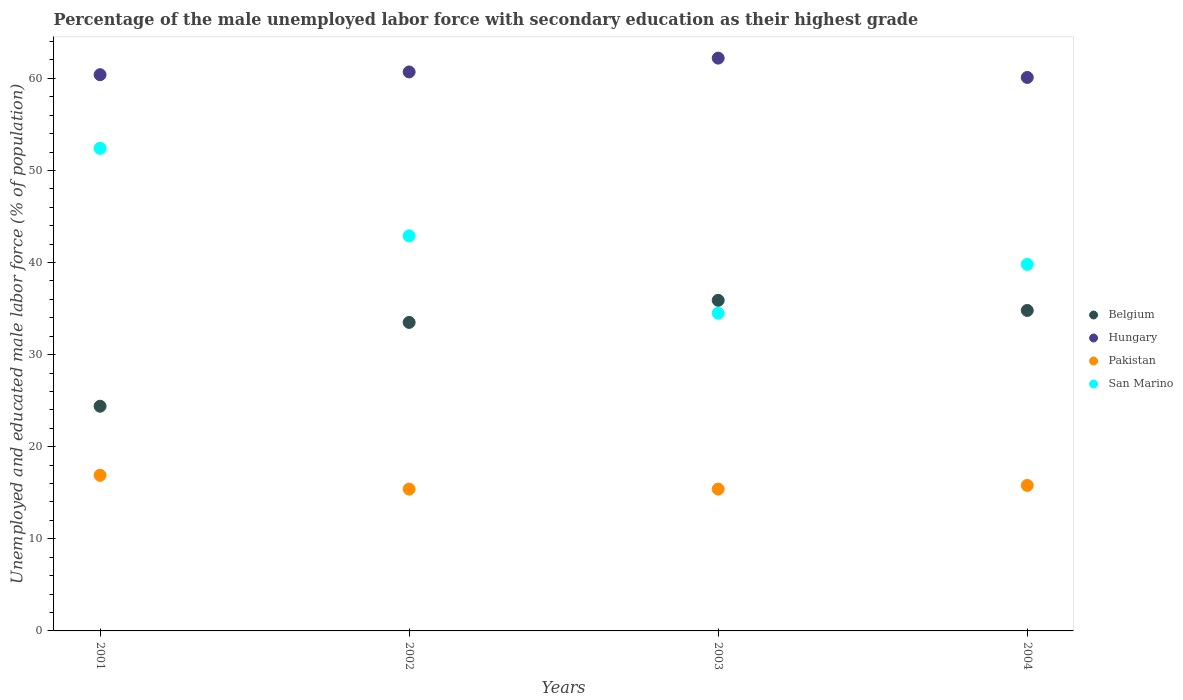How many different coloured dotlines are there?
Give a very brief answer. 4. Is the number of dotlines equal to the number of legend labels?
Your answer should be compact. Yes. What is the percentage of the unemployed male labor force with secondary education in San Marino in 2004?
Offer a very short reply. 39.8. Across all years, what is the maximum percentage of the unemployed male labor force with secondary education in San Marino?
Provide a succinct answer. 52.4. Across all years, what is the minimum percentage of the unemployed male labor force with secondary education in Belgium?
Give a very brief answer. 24.4. In which year was the percentage of the unemployed male labor force with secondary education in Belgium minimum?
Your response must be concise. 2001. What is the total percentage of the unemployed male labor force with secondary education in San Marino in the graph?
Offer a terse response. 169.6. What is the difference between the percentage of the unemployed male labor force with secondary education in Belgium in 2001 and that in 2004?
Your answer should be very brief. -10.4. What is the difference between the percentage of the unemployed male labor force with secondary education in San Marino in 2003 and the percentage of the unemployed male labor force with secondary education in Hungary in 2001?
Your answer should be compact. -25.9. What is the average percentage of the unemployed male labor force with secondary education in Pakistan per year?
Ensure brevity in your answer.  15.87. In the year 2002, what is the difference between the percentage of the unemployed male labor force with secondary education in San Marino and percentage of the unemployed male labor force with secondary education in Belgium?
Ensure brevity in your answer.  9.4. What is the difference between the highest and the second highest percentage of the unemployed male labor force with secondary education in Belgium?
Keep it short and to the point. 1.1. What is the difference between the highest and the lowest percentage of the unemployed male labor force with secondary education in Hungary?
Give a very brief answer. 2.1. Is it the case that in every year, the sum of the percentage of the unemployed male labor force with secondary education in Pakistan and percentage of the unemployed male labor force with secondary education in Belgium  is greater than the percentage of the unemployed male labor force with secondary education in Hungary?
Ensure brevity in your answer.  No. Does the percentage of the unemployed male labor force with secondary education in Belgium monotonically increase over the years?
Your answer should be compact. No. How many dotlines are there?
Provide a succinct answer. 4. How many years are there in the graph?
Make the answer very short. 4. How many legend labels are there?
Offer a terse response. 4. How are the legend labels stacked?
Offer a terse response. Vertical. What is the title of the graph?
Your response must be concise. Percentage of the male unemployed labor force with secondary education as their highest grade. What is the label or title of the X-axis?
Offer a very short reply. Years. What is the label or title of the Y-axis?
Provide a succinct answer. Unemployed and educated male labor force (% of population). What is the Unemployed and educated male labor force (% of population) of Belgium in 2001?
Keep it short and to the point. 24.4. What is the Unemployed and educated male labor force (% of population) in Hungary in 2001?
Your answer should be very brief. 60.4. What is the Unemployed and educated male labor force (% of population) of Pakistan in 2001?
Ensure brevity in your answer.  16.9. What is the Unemployed and educated male labor force (% of population) of San Marino in 2001?
Make the answer very short. 52.4. What is the Unemployed and educated male labor force (% of population) in Belgium in 2002?
Provide a succinct answer. 33.5. What is the Unemployed and educated male labor force (% of population) in Hungary in 2002?
Your answer should be very brief. 60.7. What is the Unemployed and educated male labor force (% of population) in Pakistan in 2002?
Ensure brevity in your answer.  15.4. What is the Unemployed and educated male labor force (% of population) of San Marino in 2002?
Give a very brief answer. 42.9. What is the Unemployed and educated male labor force (% of population) in Belgium in 2003?
Offer a very short reply. 35.9. What is the Unemployed and educated male labor force (% of population) in Hungary in 2003?
Keep it short and to the point. 62.2. What is the Unemployed and educated male labor force (% of population) of Pakistan in 2003?
Offer a very short reply. 15.4. What is the Unemployed and educated male labor force (% of population) of San Marino in 2003?
Make the answer very short. 34.5. What is the Unemployed and educated male labor force (% of population) in Belgium in 2004?
Provide a short and direct response. 34.8. What is the Unemployed and educated male labor force (% of population) in Hungary in 2004?
Your answer should be very brief. 60.1. What is the Unemployed and educated male labor force (% of population) in Pakistan in 2004?
Your answer should be very brief. 15.8. What is the Unemployed and educated male labor force (% of population) in San Marino in 2004?
Offer a very short reply. 39.8. Across all years, what is the maximum Unemployed and educated male labor force (% of population) of Belgium?
Offer a very short reply. 35.9. Across all years, what is the maximum Unemployed and educated male labor force (% of population) of Hungary?
Keep it short and to the point. 62.2. Across all years, what is the maximum Unemployed and educated male labor force (% of population) of Pakistan?
Make the answer very short. 16.9. Across all years, what is the maximum Unemployed and educated male labor force (% of population) in San Marino?
Your answer should be very brief. 52.4. Across all years, what is the minimum Unemployed and educated male labor force (% of population) in Belgium?
Ensure brevity in your answer.  24.4. Across all years, what is the minimum Unemployed and educated male labor force (% of population) in Hungary?
Keep it short and to the point. 60.1. Across all years, what is the minimum Unemployed and educated male labor force (% of population) of Pakistan?
Your response must be concise. 15.4. Across all years, what is the minimum Unemployed and educated male labor force (% of population) of San Marino?
Your response must be concise. 34.5. What is the total Unemployed and educated male labor force (% of population) of Belgium in the graph?
Provide a short and direct response. 128.6. What is the total Unemployed and educated male labor force (% of population) of Hungary in the graph?
Your response must be concise. 243.4. What is the total Unemployed and educated male labor force (% of population) in Pakistan in the graph?
Provide a succinct answer. 63.5. What is the total Unemployed and educated male labor force (% of population) of San Marino in the graph?
Offer a terse response. 169.6. What is the difference between the Unemployed and educated male labor force (% of population) in Belgium in 2001 and that in 2002?
Your answer should be compact. -9.1. What is the difference between the Unemployed and educated male labor force (% of population) of Hungary in 2001 and that in 2002?
Provide a succinct answer. -0.3. What is the difference between the Unemployed and educated male labor force (% of population) of Pakistan in 2001 and that in 2002?
Offer a terse response. 1.5. What is the difference between the Unemployed and educated male labor force (% of population) in San Marino in 2001 and that in 2002?
Make the answer very short. 9.5. What is the difference between the Unemployed and educated male labor force (% of population) of Belgium in 2001 and that in 2003?
Your answer should be compact. -11.5. What is the difference between the Unemployed and educated male labor force (% of population) in Hungary in 2001 and that in 2003?
Provide a succinct answer. -1.8. What is the difference between the Unemployed and educated male labor force (% of population) of Pakistan in 2001 and that in 2003?
Ensure brevity in your answer.  1.5. What is the difference between the Unemployed and educated male labor force (% of population) in Hungary in 2001 and that in 2004?
Offer a very short reply. 0.3. What is the difference between the Unemployed and educated male labor force (% of population) of Pakistan in 2001 and that in 2004?
Make the answer very short. 1.1. What is the difference between the Unemployed and educated male labor force (% of population) of Pakistan in 2002 and that in 2003?
Offer a terse response. 0. What is the difference between the Unemployed and educated male labor force (% of population) of Hungary in 2002 and that in 2004?
Ensure brevity in your answer.  0.6. What is the difference between the Unemployed and educated male labor force (% of population) of Pakistan in 2003 and that in 2004?
Your answer should be very brief. -0.4. What is the difference between the Unemployed and educated male labor force (% of population) of San Marino in 2003 and that in 2004?
Your response must be concise. -5.3. What is the difference between the Unemployed and educated male labor force (% of population) of Belgium in 2001 and the Unemployed and educated male labor force (% of population) of Hungary in 2002?
Provide a short and direct response. -36.3. What is the difference between the Unemployed and educated male labor force (% of population) of Belgium in 2001 and the Unemployed and educated male labor force (% of population) of Pakistan in 2002?
Offer a terse response. 9. What is the difference between the Unemployed and educated male labor force (% of population) in Belgium in 2001 and the Unemployed and educated male labor force (% of population) in San Marino in 2002?
Ensure brevity in your answer.  -18.5. What is the difference between the Unemployed and educated male labor force (% of population) of Hungary in 2001 and the Unemployed and educated male labor force (% of population) of Pakistan in 2002?
Give a very brief answer. 45. What is the difference between the Unemployed and educated male labor force (% of population) of Hungary in 2001 and the Unemployed and educated male labor force (% of population) of San Marino in 2002?
Offer a very short reply. 17.5. What is the difference between the Unemployed and educated male labor force (% of population) in Pakistan in 2001 and the Unemployed and educated male labor force (% of population) in San Marino in 2002?
Offer a very short reply. -26. What is the difference between the Unemployed and educated male labor force (% of population) of Belgium in 2001 and the Unemployed and educated male labor force (% of population) of Hungary in 2003?
Make the answer very short. -37.8. What is the difference between the Unemployed and educated male labor force (% of population) of Belgium in 2001 and the Unemployed and educated male labor force (% of population) of Pakistan in 2003?
Your response must be concise. 9. What is the difference between the Unemployed and educated male labor force (% of population) of Hungary in 2001 and the Unemployed and educated male labor force (% of population) of San Marino in 2003?
Offer a very short reply. 25.9. What is the difference between the Unemployed and educated male labor force (% of population) in Pakistan in 2001 and the Unemployed and educated male labor force (% of population) in San Marino in 2003?
Make the answer very short. -17.6. What is the difference between the Unemployed and educated male labor force (% of population) in Belgium in 2001 and the Unemployed and educated male labor force (% of population) in Hungary in 2004?
Give a very brief answer. -35.7. What is the difference between the Unemployed and educated male labor force (% of population) of Belgium in 2001 and the Unemployed and educated male labor force (% of population) of Pakistan in 2004?
Provide a succinct answer. 8.6. What is the difference between the Unemployed and educated male labor force (% of population) in Belgium in 2001 and the Unemployed and educated male labor force (% of population) in San Marino in 2004?
Provide a succinct answer. -15.4. What is the difference between the Unemployed and educated male labor force (% of population) of Hungary in 2001 and the Unemployed and educated male labor force (% of population) of Pakistan in 2004?
Make the answer very short. 44.6. What is the difference between the Unemployed and educated male labor force (% of population) in Hungary in 2001 and the Unemployed and educated male labor force (% of population) in San Marino in 2004?
Offer a very short reply. 20.6. What is the difference between the Unemployed and educated male labor force (% of population) of Pakistan in 2001 and the Unemployed and educated male labor force (% of population) of San Marino in 2004?
Your answer should be compact. -22.9. What is the difference between the Unemployed and educated male labor force (% of population) in Belgium in 2002 and the Unemployed and educated male labor force (% of population) in Hungary in 2003?
Provide a short and direct response. -28.7. What is the difference between the Unemployed and educated male labor force (% of population) in Belgium in 2002 and the Unemployed and educated male labor force (% of population) in San Marino in 2003?
Offer a very short reply. -1. What is the difference between the Unemployed and educated male labor force (% of population) of Hungary in 2002 and the Unemployed and educated male labor force (% of population) of Pakistan in 2003?
Give a very brief answer. 45.3. What is the difference between the Unemployed and educated male labor force (% of population) of Hungary in 2002 and the Unemployed and educated male labor force (% of population) of San Marino in 2003?
Your answer should be very brief. 26.2. What is the difference between the Unemployed and educated male labor force (% of population) of Pakistan in 2002 and the Unemployed and educated male labor force (% of population) of San Marino in 2003?
Offer a terse response. -19.1. What is the difference between the Unemployed and educated male labor force (% of population) of Belgium in 2002 and the Unemployed and educated male labor force (% of population) of Hungary in 2004?
Your answer should be very brief. -26.6. What is the difference between the Unemployed and educated male labor force (% of population) of Belgium in 2002 and the Unemployed and educated male labor force (% of population) of San Marino in 2004?
Your answer should be very brief. -6.3. What is the difference between the Unemployed and educated male labor force (% of population) in Hungary in 2002 and the Unemployed and educated male labor force (% of population) in Pakistan in 2004?
Make the answer very short. 44.9. What is the difference between the Unemployed and educated male labor force (% of population) of Hungary in 2002 and the Unemployed and educated male labor force (% of population) of San Marino in 2004?
Ensure brevity in your answer.  20.9. What is the difference between the Unemployed and educated male labor force (% of population) in Pakistan in 2002 and the Unemployed and educated male labor force (% of population) in San Marino in 2004?
Make the answer very short. -24.4. What is the difference between the Unemployed and educated male labor force (% of population) of Belgium in 2003 and the Unemployed and educated male labor force (% of population) of Hungary in 2004?
Provide a short and direct response. -24.2. What is the difference between the Unemployed and educated male labor force (% of population) in Belgium in 2003 and the Unemployed and educated male labor force (% of population) in Pakistan in 2004?
Your response must be concise. 20.1. What is the difference between the Unemployed and educated male labor force (% of population) in Hungary in 2003 and the Unemployed and educated male labor force (% of population) in Pakistan in 2004?
Give a very brief answer. 46.4. What is the difference between the Unemployed and educated male labor force (% of population) of Hungary in 2003 and the Unemployed and educated male labor force (% of population) of San Marino in 2004?
Offer a very short reply. 22.4. What is the difference between the Unemployed and educated male labor force (% of population) of Pakistan in 2003 and the Unemployed and educated male labor force (% of population) of San Marino in 2004?
Your response must be concise. -24.4. What is the average Unemployed and educated male labor force (% of population) in Belgium per year?
Offer a terse response. 32.15. What is the average Unemployed and educated male labor force (% of population) in Hungary per year?
Give a very brief answer. 60.85. What is the average Unemployed and educated male labor force (% of population) of Pakistan per year?
Make the answer very short. 15.88. What is the average Unemployed and educated male labor force (% of population) in San Marino per year?
Give a very brief answer. 42.4. In the year 2001, what is the difference between the Unemployed and educated male labor force (% of population) of Belgium and Unemployed and educated male labor force (% of population) of Hungary?
Make the answer very short. -36. In the year 2001, what is the difference between the Unemployed and educated male labor force (% of population) of Belgium and Unemployed and educated male labor force (% of population) of Pakistan?
Provide a succinct answer. 7.5. In the year 2001, what is the difference between the Unemployed and educated male labor force (% of population) of Hungary and Unemployed and educated male labor force (% of population) of Pakistan?
Keep it short and to the point. 43.5. In the year 2001, what is the difference between the Unemployed and educated male labor force (% of population) in Hungary and Unemployed and educated male labor force (% of population) in San Marino?
Offer a terse response. 8. In the year 2001, what is the difference between the Unemployed and educated male labor force (% of population) in Pakistan and Unemployed and educated male labor force (% of population) in San Marino?
Ensure brevity in your answer.  -35.5. In the year 2002, what is the difference between the Unemployed and educated male labor force (% of population) in Belgium and Unemployed and educated male labor force (% of population) in Hungary?
Give a very brief answer. -27.2. In the year 2002, what is the difference between the Unemployed and educated male labor force (% of population) in Belgium and Unemployed and educated male labor force (% of population) in Pakistan?
Provide a succinct answer. 18.1. In the year 2002, what is the difference between the Unemployed and educated male labor force (% of population) of Belgium and Unemployed and educated male labor force (% of population) of San Marino?
Make the answer very short. -9.4. In the year 2002, what is the difference between the Unemployed and educated male labor force (% of population) of Hungary and Unemployed and educated male labor force (% of population) of Pakistan?
Keep it short and to the point. 45.3. In the year 2002, what is the difference between the Unemployed and educated male labor force (% of population) in Hungary and Unemployed and educated male labor force (% of population) in San Marino?
Provide a succinct answer. 17.8. In the year 2002, what is the difference between the Unemployed and educated male labor force (% of population) in Pakistan and Unemployed and educated male labor force (% of population) in San Marino?
Provide a short and direct response. -27.5. In the year 2003, what is the difference between the Unemployed and educated male labor force (% of population) in Belgium and Unemployed and educated male labor force (% of population) in Hungary?
Provide a short and direct response. -26.3. In the year 2003, what is the difference between the Unemployed and educated male labor force (% of population) in Belgium and Unemployed and educated male labor force (% of population) in San Marino?
Your answer should be very brief. 1.4. In the year 2003, what is the difference between the Unemployed and educated male labor force (% of population) of Hungary and Unemployed and educated male labor force (% of population) of Pakistan?
Your answer should be compact. 46.8. In the year 2003, what is the difference between the Unemployed and educated male labor force (% of population) in Hungary and Unemployed and educated male labor force (% of population) in San Marino?
Give a very brief answer. 27.7. In the year 2003, what is the difference between the Unemployed and educated male labor force (% of population) of Pakistan and Unemployed and educated male labor force (% of population) of San Marino?
Provide a short and direct response. -19.1. In the year 2004, what is the difference between the Unemployed and educated male labor force (% of population) in Belgium and Unemployed and educated male labor force (% of population) in Hungary?
Your answer should be very brief. -25.3. In the year 2004, what is the difference between the Unemployed and educated male labor force (% of population) of Belgium and Unemployed and educated male labor force (% of population) of Pakistan?
Offer a terse response. 19. In the year 2004, what is the difference between the Unemployed and educated male labor force (% of population) of Hungary and Unemployed and educated male labor force (% of population) of Pakistan?
Provide a succinct answer. 44.3. In the year 2004, what is the difference between the Unemployed and educated male labor force (% of population) in Hungary and Unemployed and educated male labor force (% of population) in San Marino?
Your answer should be very brief. 20.3. What is the ratio of the Unemployed and educated male labor force (% of population) of Belgium in 2001 to that in 2002?
Make the answer very short. 0.73. What is the ratio of the Unemployed and educated male labor force (% of population) in Hungary in 2001 to that in 2002?
Offer a terse response. 1. What is the ratio of the Unemployed and educated male labor force (% of population) in Pakistan in 2001 to that in 2002?
Ensure brevity in your answer.  1.1. What is the ratio of the Unemployed and educated male labor force (% of population) of San Marino in 2001 to that in 2002?
Keep it short and to the point. 1.22. What is the ratio of the Unemployed and educated male labor force (% of population) in Belgium in 2001 to that in 2003?
Provide a short and direct response. 0.68. What is the ratio of the Unemployed and educated male labor force (% of population) in Hungary in 2001 to that in 2003?
Offer a terse response. 0.97. What is the ratio of the Unemployed and educated male labor force (% of population) in Pakistan in 2001 to that in 2003?
Your answer should be compact. 1.1. What is the ratio of the Unemployed and educated male labor force (% of population) in San Marino in 2001 to that in 2003?
Ensure brevity in your answer.  1.52. What is the ratio of the Unemployed and educated male labor force (% of population) of Belgium in 2001 to that in 2004?
Offer a very short reply. 0.7. What is the ratio of the Unemployed and educated male labor force (% of population) of Pakistan in 2001 to that in 2004?
Ensure brevity in your answer.  1.07. What is the ratio of the Unemployed and educated male labor force (% of population) in San Marino in 2001 to that in 2004?
Offer a very short reply. 1.32. What is the ratio of the Unemployed and educated male labor force (% of population) of Belgium in 2002 to that in 2003?
Offer a very short reply. 0.93. What is the ratio of the Unemployed and educated male labor force (% of population) in Hungary in 2002 to that in 2003?
Keep it short and to the point. 0.98. What is the ratio of the Unemployed and educated male labor force (% of population) in San Marino in 2002 to that in 2003?
Offer a terse response. 1.24. What is the ratio of the Unemployed and educated male labor force (% of population) of Belgium in 2002 to that in 2004?
Your answer should be very brief. 0.96. What is the ratio of the Unemployed and educated male labor force (% of population) in Pakistan in 2002 to that in 2004?
Give a very brief answer. 0.97. What is the ratio of the Unemployed and educated male labor force (% of population) of San Marino in 2002 to that in 2004?
Your answer should be compact. 1.08. What is the ratio of the Unemployed and educated male labor force (% of population) of Belgium in 2003 to that in 2004?
Ensure brevity in your answer.  1.03. What is the ratio of the Unemployed and educated male labor force (% of population) in Hungary in 2003 to that in 2004?
Your answer should be very brief. 1.03. What is the ratio of the Unemployed and educated male labor force (% of population) of Pakistan in 2003 to that in 2004?
Ensure brevity in your answer.  0.97. What is the ratio of the Unemployed and educated male labor force (% of population) in San Marino in 2003 to that in 2004?
Provide a short and direct response. 0.87. What is the difference between the highest and the second highest Unemployed and educated male labor force (% of population) in Hungary?
Your answer should be very brief. 1.5. What is the difference between the highest and the second highest Unemployed and educated male labor force (% of population) in Pakistan?
Your response must be concise. 1.1. What is the difference between the highest and the lowest Unemployed and educated male labor force (% of population) of Belgium?
Your answer should be very brief. 11.5. What is the difference between the highest and the lowest Unemployed and educated male labor force (% of population) of Hungary?
Give a very brief answer. 2.1. What is the difference between the highest and the lowest Unemployed and educated male labor force (% of population) of Pakistan?
Make the answer very short. 1.5. What is the difference between the highest and the lowest Unemployed and educated male labor force (% of population) in San Marino?
Keep it short and to the point. 17.9. 